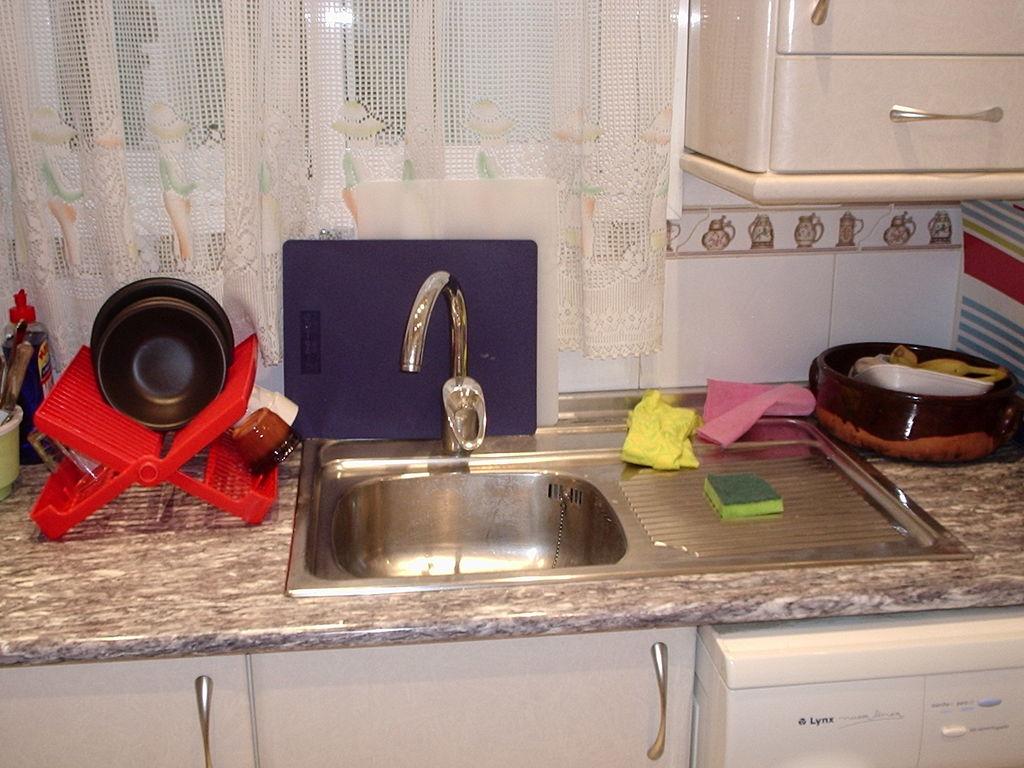What color is the brand name on the dishwasher written in?
Make the answer very short. Black. 